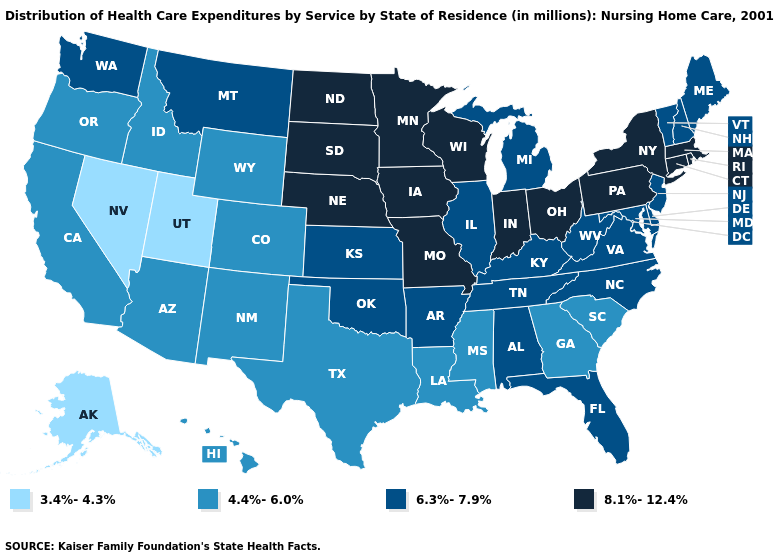Which states have the lowest value in the Northeast?
Answer briefly. Maine, New Hampshire, New Jersey, Vermont. What is the value of Rhode Island?
Quick response, please. 8.1%-12.4%. Which states have the highest value in the USA?
Short answer required. Connecticut, Indiana, Iowa, Massachusetts, Minnesota, Missouri, Nebraska, New York, North Dakota, Ohio, Pennsylvania, Rhode Island, South Dakota, Wisconsin. What is the highest value in the Northeast ?
Give a very brief answer. 8.1%-12.4%. Does Kansas have a lower value than New Jersey?
Give a very brief answer. No. What is the highest value in states that border Montana?
Give a very brief answer. 8.1%-12.4%. Does South Carolina have the highest value in the South?
Give a very brief answer. No. Which states hav the highest value in the MidWest?
Answer briefly. Indiana, Iowa, Minnesota, Missouri, Nebraska, North Dakota, Ohio, South Dakota, Wisconsin. Does Texas have a lower value than Kansas?
Concise answer only. Yes. Name the states that have a value in the range 3.4%-4.3%?
Concise answer only. Alaska, Nevada, Utah. Among the states that border Texas , does Louisiana have the lowest value?
Write a very short answer. Yes. What is the value of Illinois?
Give a very brief answer. 6.3%-7.9%. What is the value of Colorado?
Answer briefly. 4.4%-6.0%. Does North Carolina have a higher value than Wisconsin?
Short answer required. No. Which states hav the highest value in the West?
Give a very brief answer. Montana, Washington. 